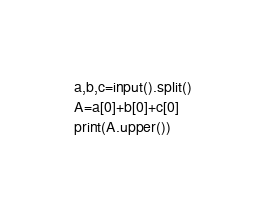<code> <loc_0><loc_0><loc_500><loc_500><_Python_>a,b,c=input().split()
A=a[0]+b[0]+c[0]
print(A.upper())</code> 